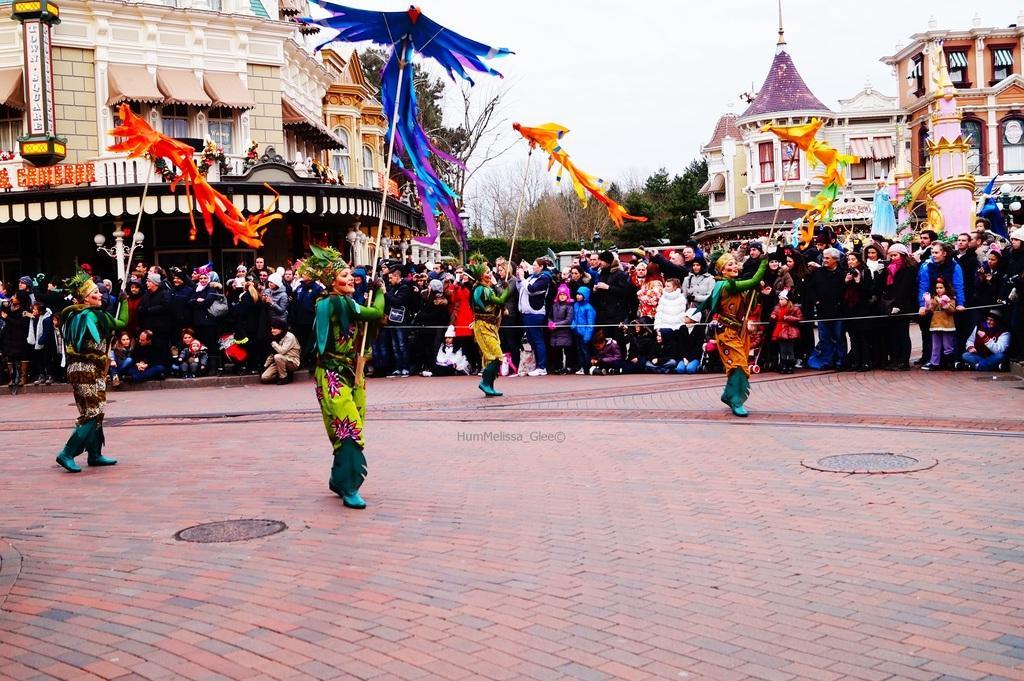How would you summarize this image in a sentence or two? In this image we can see persons performing on the road. In the background there is crowd, buildings, trees and sky. 